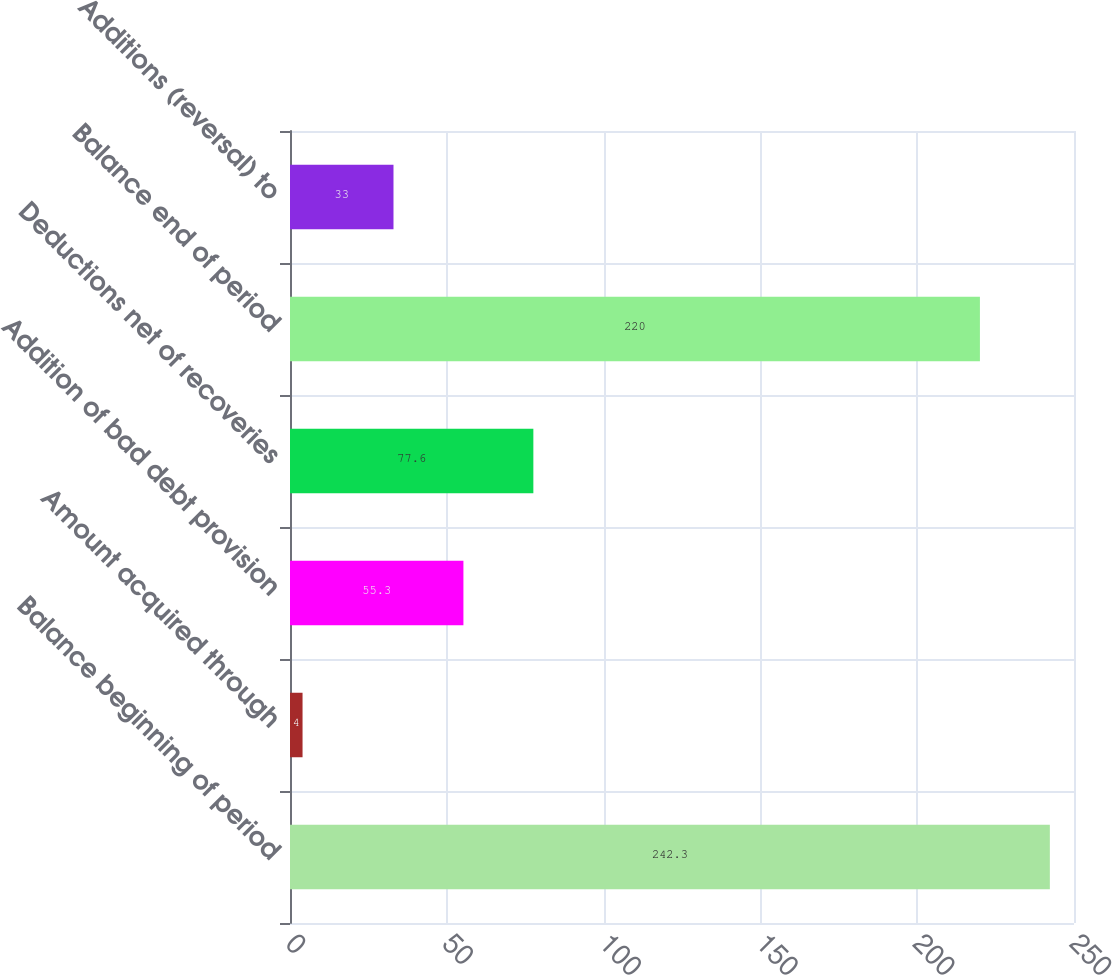Convert chart to OTSL. <chart><loc_0><loc_0><loc_500><loc_500><bar_chart><fcel>Balance beginning of period<fcel>Amount acquired through<fcel>Addition of bad debt provision<fcel>Deductions net of recoveries<fcel>Balance end of period<fcel>Additions (reversal) to<nl><fcel>242.3<fcel>4<fcel>55.3<fcel>77.6<fcel>220<fcel>33<nl></chart> 